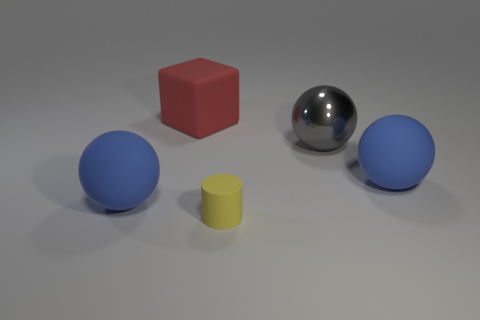How many tiny matte things are the same color as the matte block?
Give a very brief answer. 0. Are there more blue things in front of the yellow rubber cylinder than big blue things?
Ensure brevity in your answer.  No. There is a thing in front of the object that is to the left of the cube; what color is it?
Your answer should be compact. Yellow. How many things are either blue things that are to the right of the small object or matte spheres that are to the left of the tiny yellow thing?
Ensure brevity in your answer.  2. The metal object is what color?
Provide a short and direct response. Gray. How many small things have the same material as the red block?
Provide a short and direct response. 1. Are there more big red matte cubes than small green metallic cubes?
Give a very brief answer. Yes. There is a blue thing left of the metal object; how many large things are behind it?
Your answer should be very brief. 3. How many things are large things that are to the right of the yellow rubber object or gray metal spheres?
Give a very brief answer. 2. Is there another blue rubber object that has the same shape as the small object?
Ensure brevity in your answer.  No. 